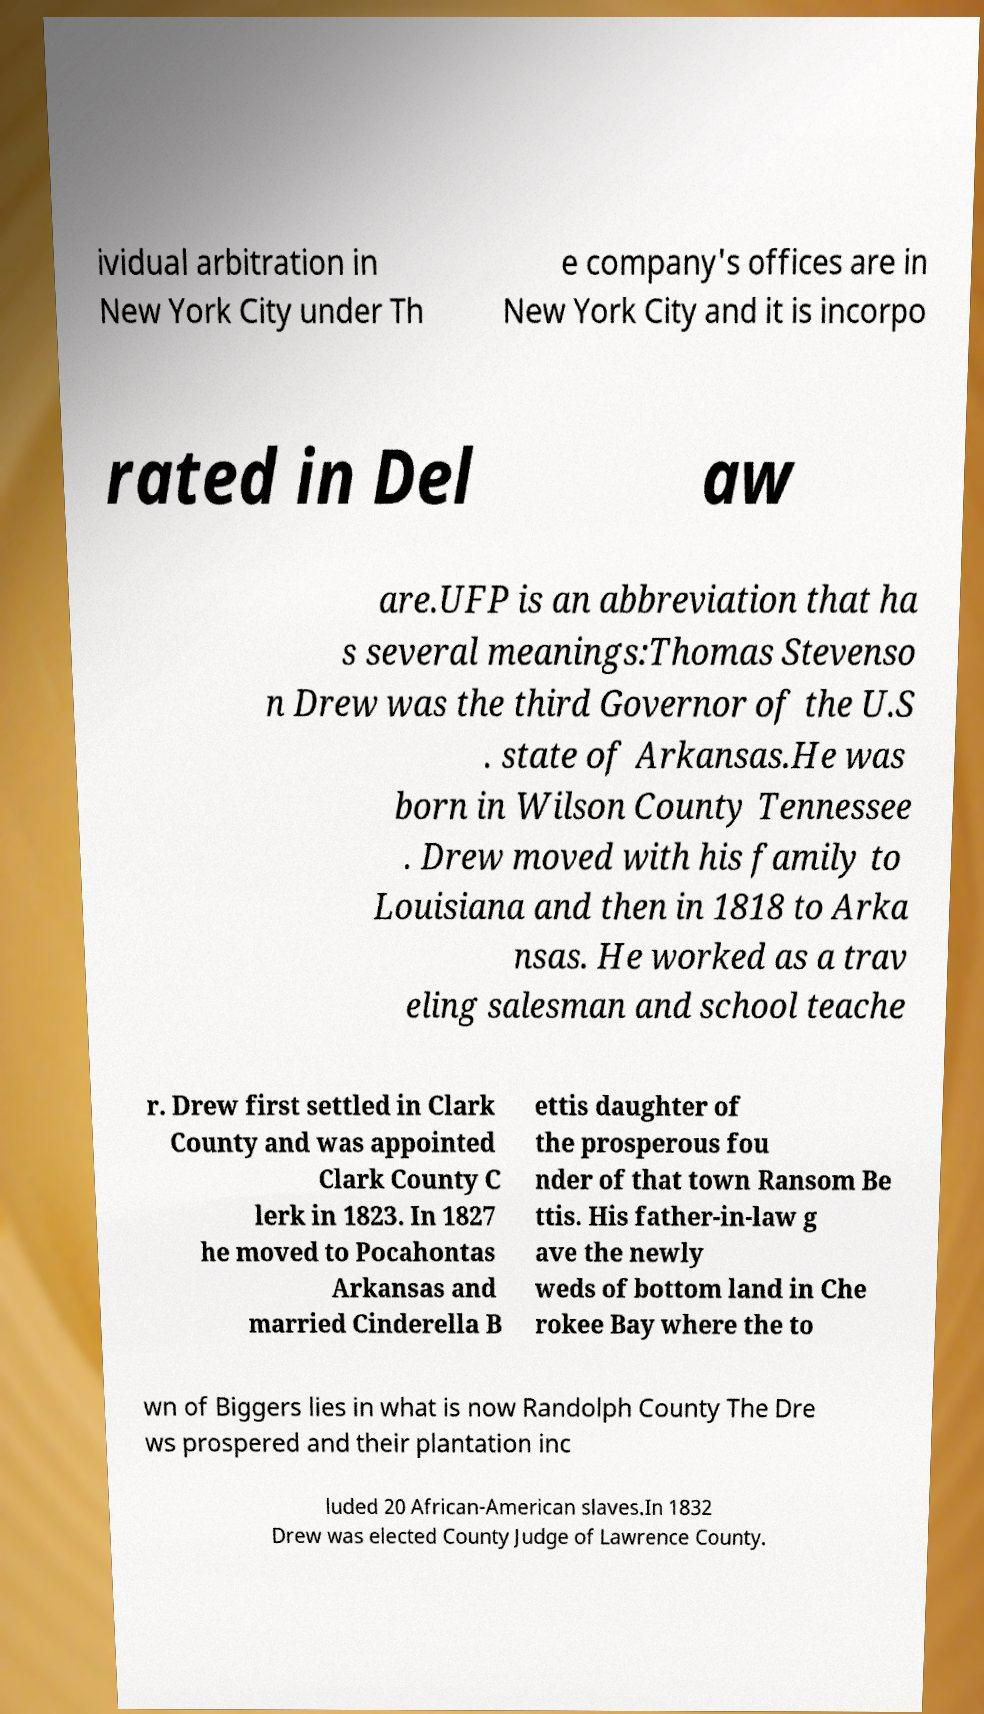Can you accurately transcribe the text from the provided image for me? ividual arbitration in New York City under Th e company's offices are in New York City and it is incorpo rated in Del aw are.UFP is an abbreviation that ha s several meanings:Thomas Stevenso n Drew was the third Governor of the U.S . state of Arkansas.He was born in Wilson County Tennessee . Drew moved with his family to Louisiana and then in 1818 to Arka nsas. He worked as a trav eling salesman and school teache r. Drew first settled in Clark County and was appointed Clark County C lerk in 1823. In 1827 he moved to Pocahontas Arkansas and married Cinderella B ettis daughter of the prosperous fou nder of that town Ransom Be ttis. His father-in-law g ave the newly weds of bottom land in Che rokee Bay where the to wn of Biggers lies in what is now Randolph County The Dre ws prospered and their plantation inc luded 20 African-American slaves.In 1832 Drew was elected County Judge of Lawrence County. 